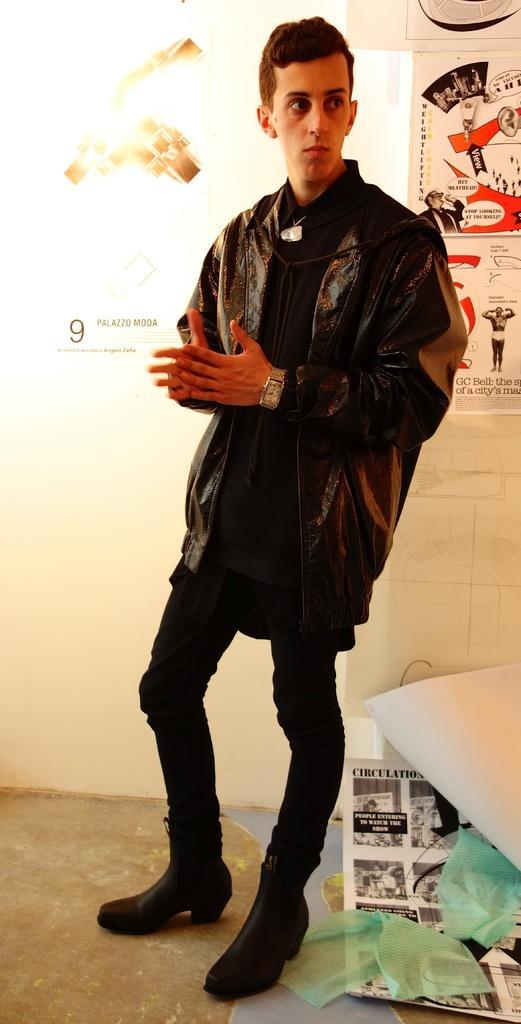Describe this image in one or two sentences. In this picture we can see a man in the black jacket is standing on the floor and on the right side of the man there are news papers and some objects. Behind the man there is a wall with posters. 